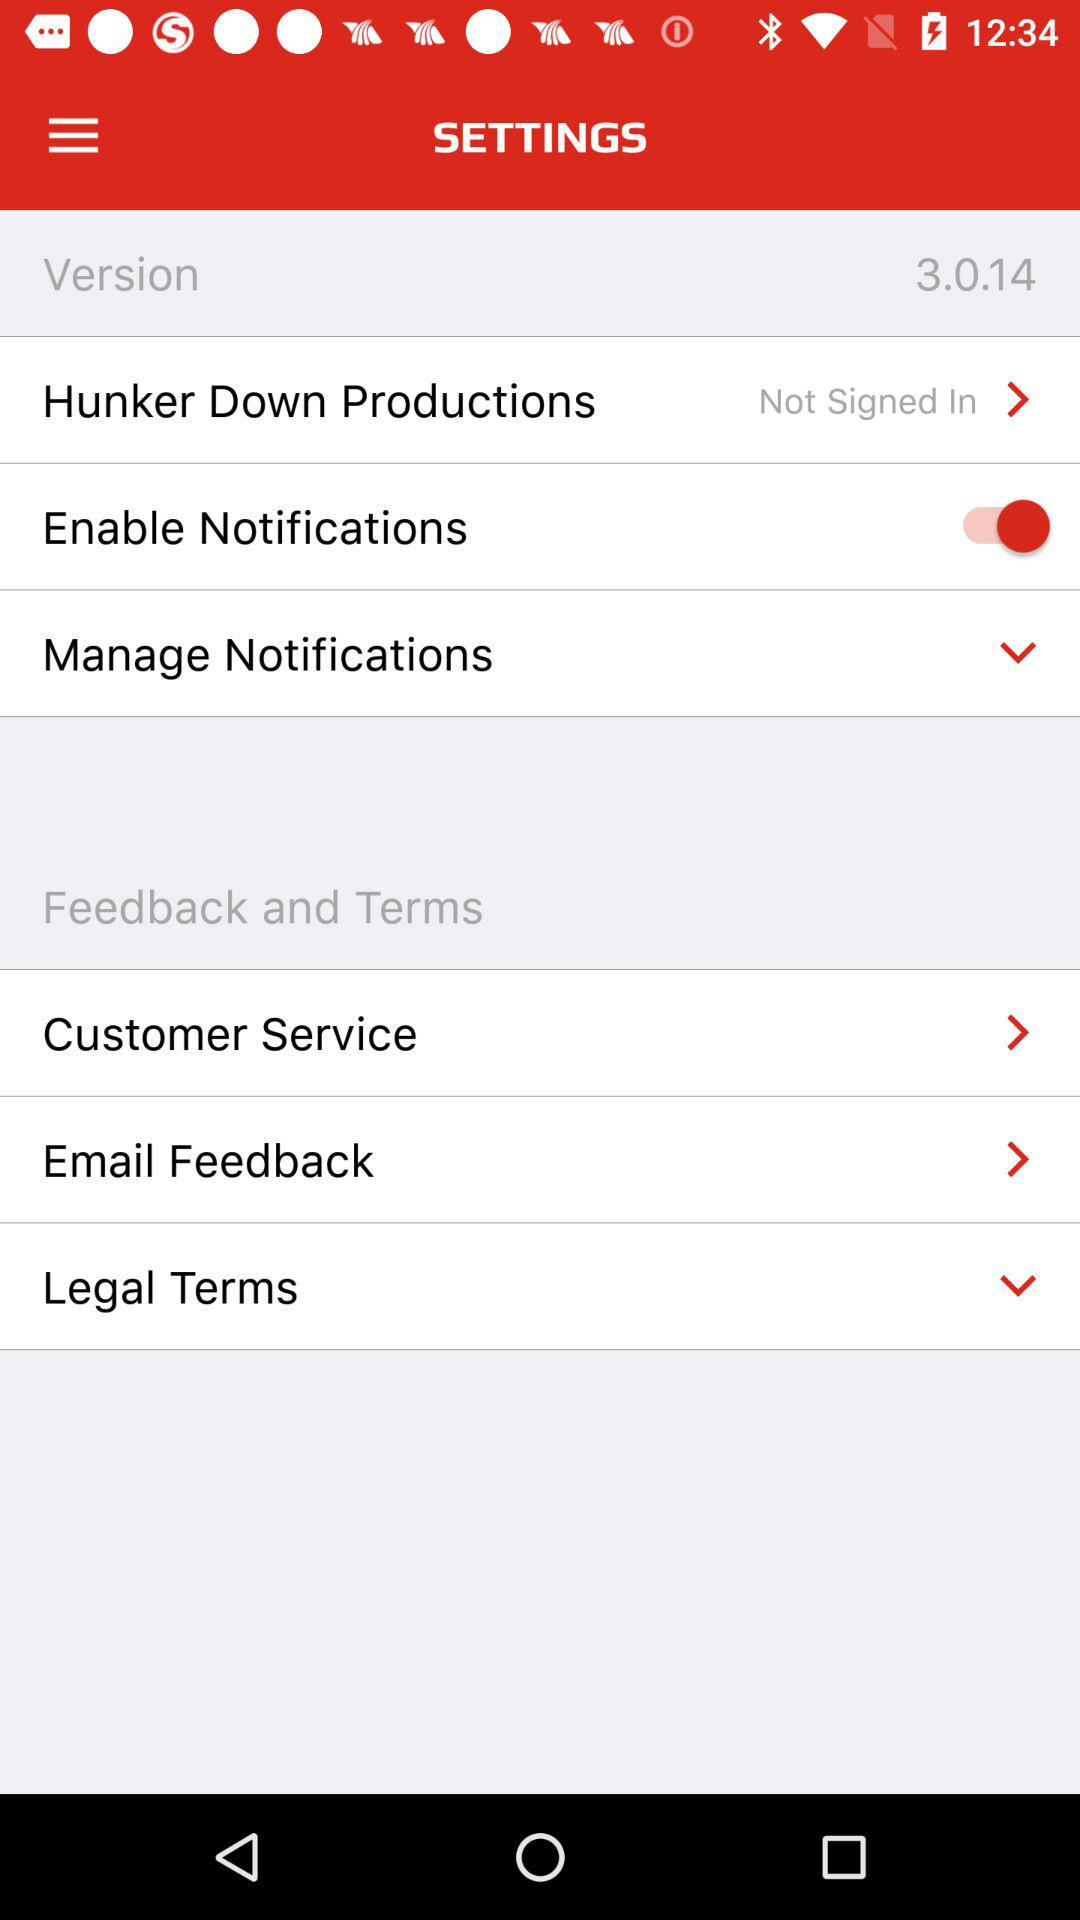How many items have a switch in the Settings menu?
Answer the question using a single word or phrase. 1 